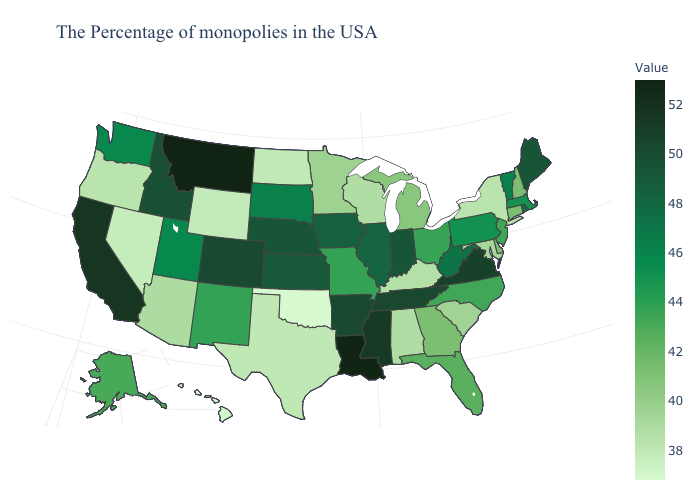Among the states that border Missouri , which have the lowest value?
Quick response, please. Oklahoma. Among the states that border Iowa , does Missouri have the lowest value?
Keep it brief. No. Among the states that border Washington , does Oregon have the highest value?
Short answer required. No. Which states have the highest value in the USA?
Give a very brief answer. Montana. Does the map have missing data?
Answer briefly. No. Among the states that border Indiana , does Michigan have the lowest value?
Concise answer only. No. Does Illinois have the highest value in the USA?
Give a very brief answer. No. 